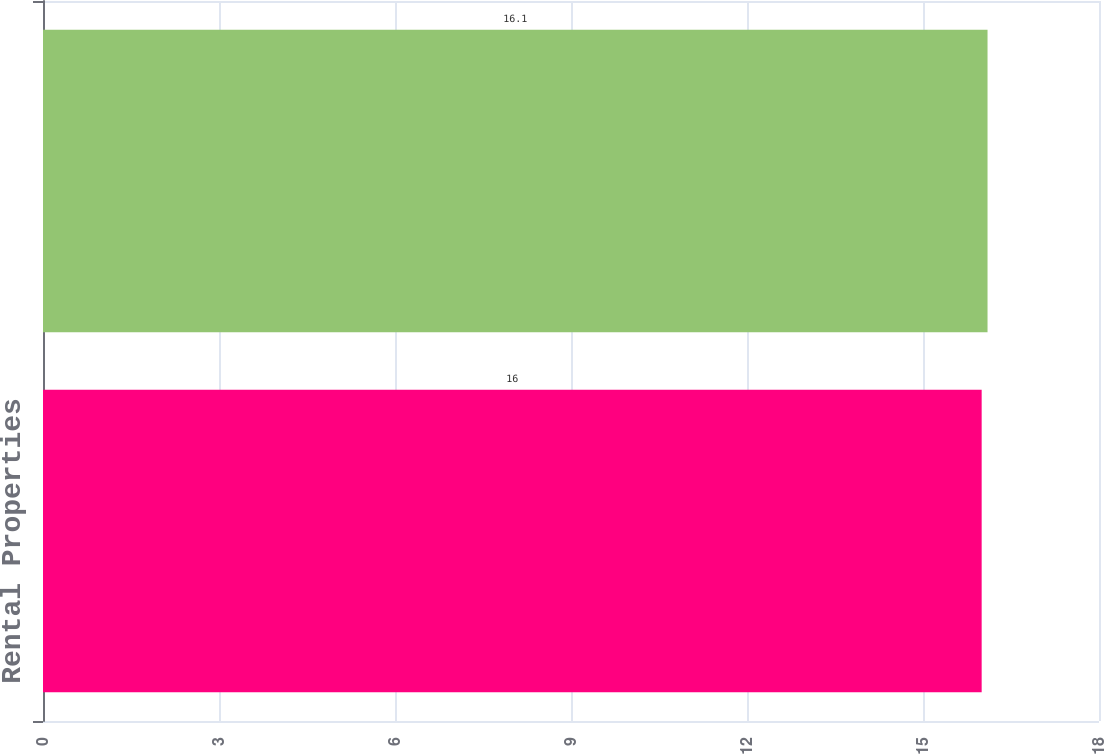Convert chart. <chart><loc_0><loc_0><loc_500><loc_500><bar_chart><fcel>Rental Properties<fcel>Total<nl><fcel>16<fcel>16.1<nl></chart> 